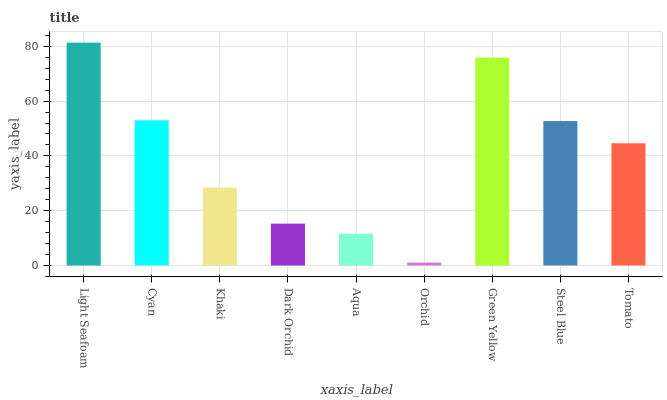Is Orchid the minimum?
Answer yes or no. Yes. Is Light Seafoam the maximum?
Answer yes or no. Yes. Is Cyan the minimum?
Answer yes or no. No. Is Cyan the maximum?
Answer yes or no. No. Is Light Seafoam greater than Cyan?
Answer yes or no. Yes. Is Cyan less than Light Seafoam?
Answer yes or no. Yes. Is Cyan greater than Light Seafoam?
Answer yes or no. No. Is Light Seafoam less than Cyan?
Answer yes or no. No. Is Tomato the high median?
Answer yes or no. Yes. Is Tomato the low median?
Answer yes or no. Yes. Is Dark Orchid the high median?
Answer yes or no. No. Is Green Yellow the low median?
Answer yes or no. No. 